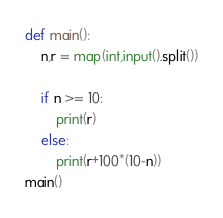Convert code to text. <code><loc_0><loc_0><loc_500><loc_500><_Python_>def main():
    n,r = map(int,input().split())

    if n >= 10:
        print(r)
    else:
        print(r+100*(10-n))
main()</code> 